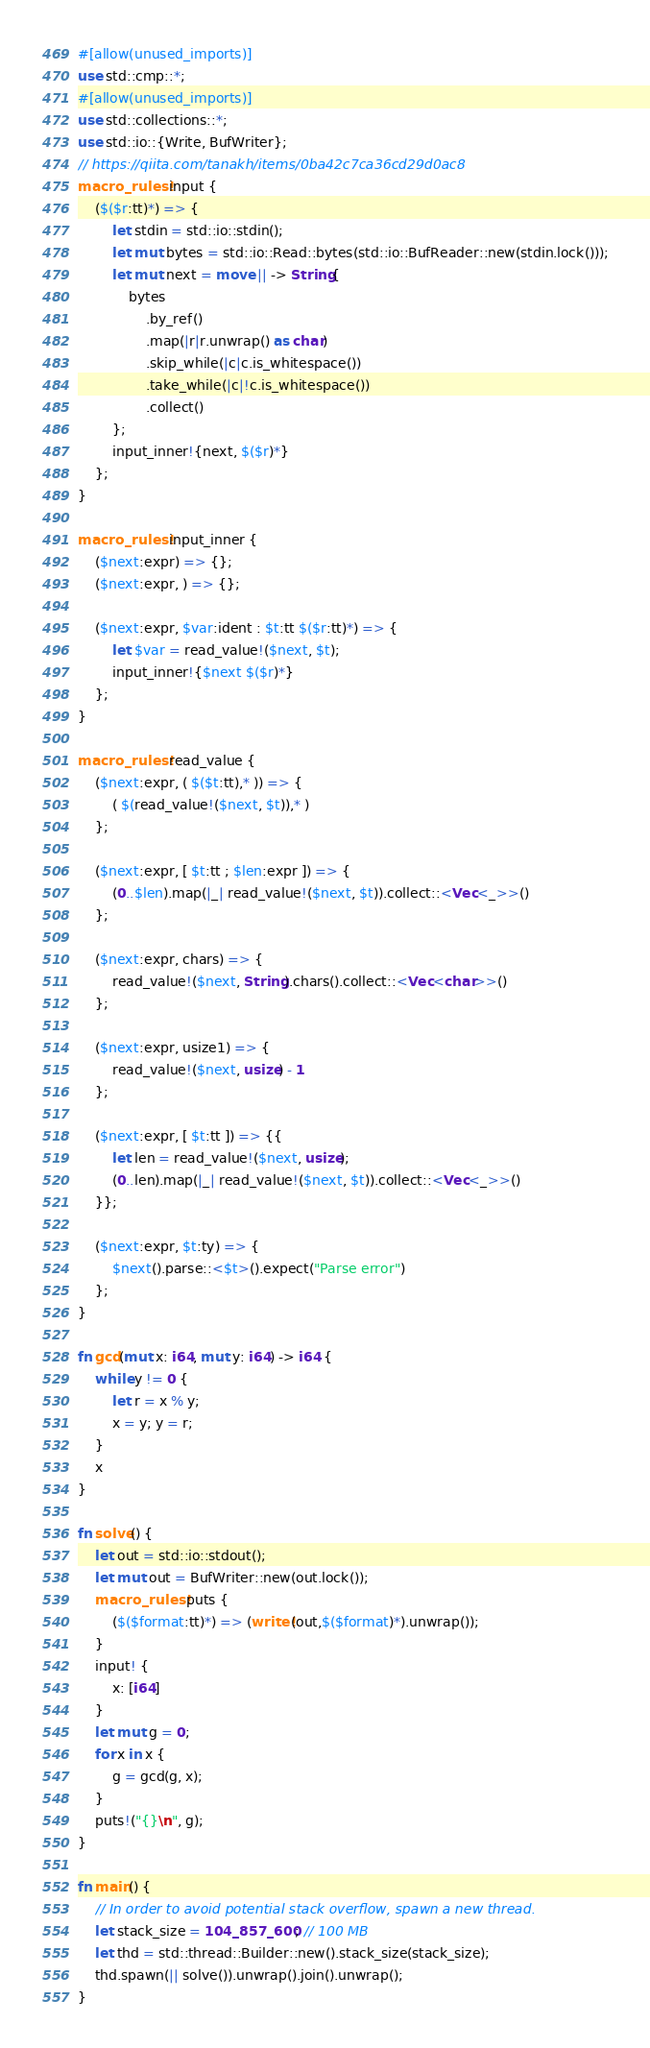Convert code to text. <code><loc_0><loc_0><loc_500><loc_500><_Rust_>#[allow(unused_imports)]
use std::cmp::*;
#[allow(unused_imports)]
use std::collections::*;
use std::io::{Write, BufWriter};
// https://qiita.com/tanakh/items/0ba42c7ca36cd29d0ac8
macro_rules! input {
    ($($r:tt)*) => {
        let stdin = std::io::stdin();
        let mut bytes = std::io::Read::bytes(std::io::BufReader::new(stdin.lock()));
        let mut next = move || -> String{
            bytes
                .by_ref()
                .map(|r|r.unwrap() as char)
                .skip_while(|c|c.is_whitespace())
                .take_while(|c|!c.is_whitespace())
                .collect()
        };
        input_inner!{next, $($r)*}
    };
}

macro_rules! input_inner {
    ($next:expr) => {};
    ($next:expr, ) => {};

    ($next:expr, $var:ident : $t:tt $($r:tt)*) => {
        let $var = read_value!($next, $t);
        input_inner!{$next $($r)*}
    };
}

macro_rules! read_value {
    ($next:expr, ( $($t:tt),* )) => {
        ( $(read_value!($next, $t)),* )
    };

    ($next:expr, [ $t:tt ; $len:expr ]) => {
        (0..$len).map(|_| read_value!($next, $t)).collect::<Vec<_>>()
    };

    ($next:expr, chars) => {
        read_value!($next, String).chars().collect::<Vec<char>>()
    };

    ($next:expr, usize1) => {
        read_value!($next, usize) - 1
    };

    ($next:expr, [ $t:tt ]) => {{
        let len = read_value!($next, usize);
        (0..len).map(|_| read_value!($next, $t)).collect::<Vec<_>>()
    }};

    ($next:expr, $t:ty) => {
        $next().parse::<$t>().expect("Parse error")
    };
}

fn gcd(mut x: i64, mut y: i64) -> i64 {
    while y != 0 {
        let r = x % y;
        x = y; y = r;
    }
    x
}

fn solve() {
    let out = std::io::stdout();
    let mut out = BufWriter::new(out.lock());
    macro_rules! puts {
        ($($format:tt)*) => (write!(out,$($format)*).unwrap());
    }
    input! {
        x: [i64]
    }
    let mut g = 0;
    for x in x {
        g = gcd(g, x);
    }
    puts!("{}\n", g);
}

fn main() {
    // In order to avoid potential stack overflow, spawn a new thread.
    let stack_size = 104_857_600; // 100 MB
    let thd = std::thread::Builder::new().stack_size(stack_size);
    thd.spawn(|| solve()).unwrap().join().unwrap();
}
</code> 